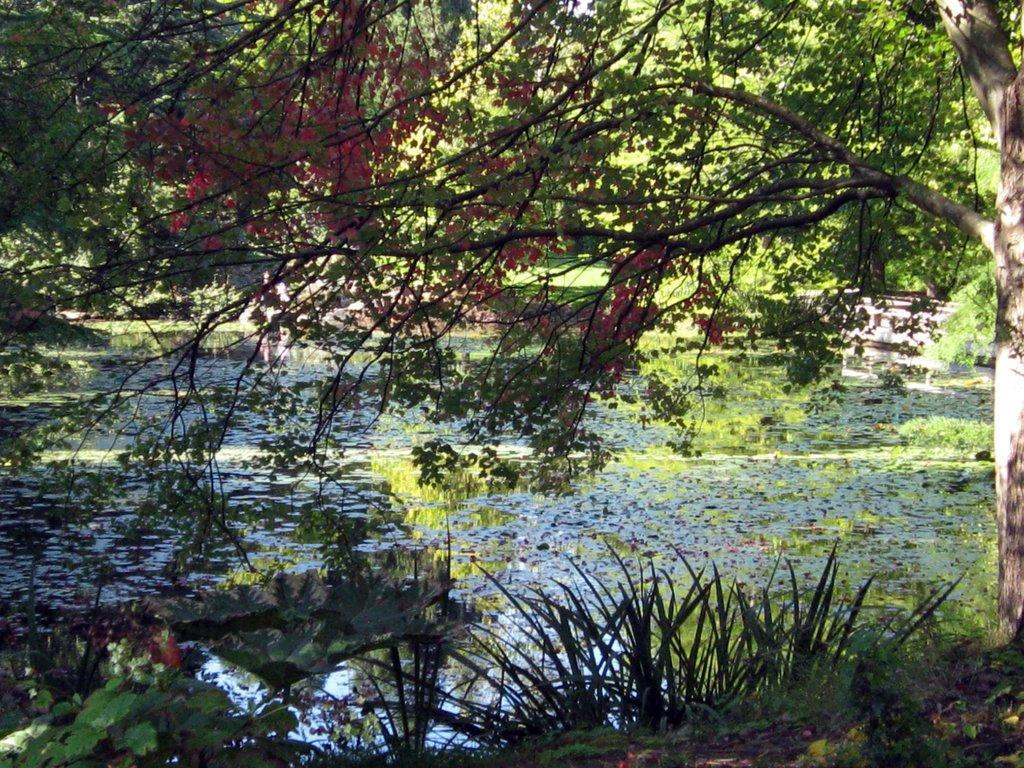What type of vegetation is in the front of the image? There are plants in the front of the image. Can you describe the tree in the image? There is a tree in the image. What is located in the center of the image? There is water in the center of the image. What can be seen in the background of the image? There are trees in the background of the image. What type of sand can be seen on the tree in the image? There is no sand present in the image; it features plants, a tree, water, and trees in the background. How much salt is visible on the plants in the image? There is no salt visible on the plants in the image. 